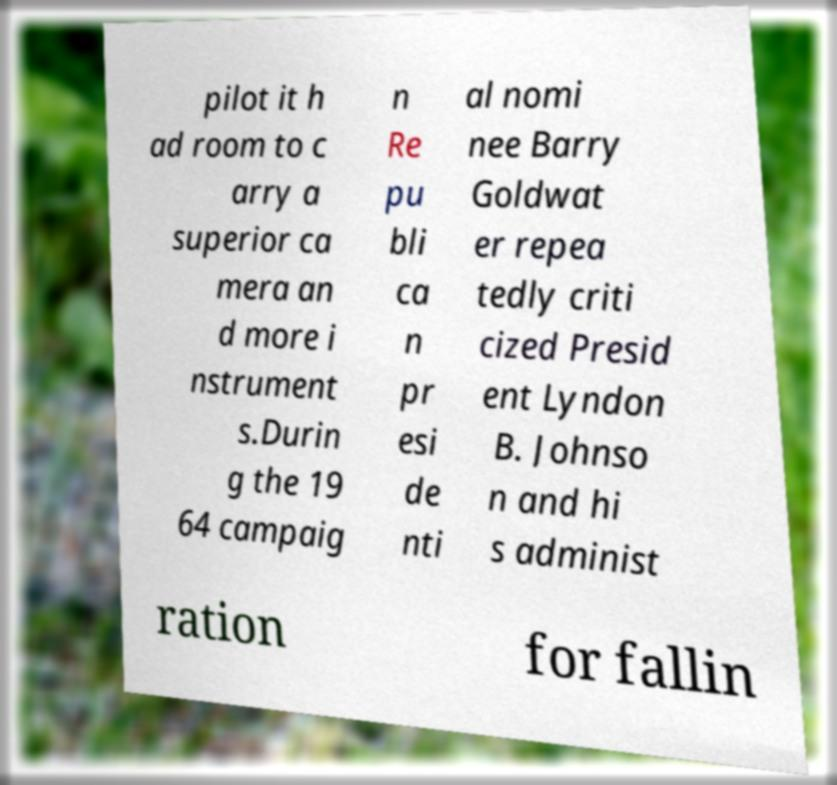Can you accurately transcribe the text from the provided image for me? pilot it h ad room to c arry a superior ca mera an d more i nstrument s.Durin g the 19 64 campaig n Re pu bli ca n pr esi de nti al nomi nee Barry Goldwat er repea tedly criti cized Presid ent Lyndon B. Johnso n and hi s administ ration for fallin 